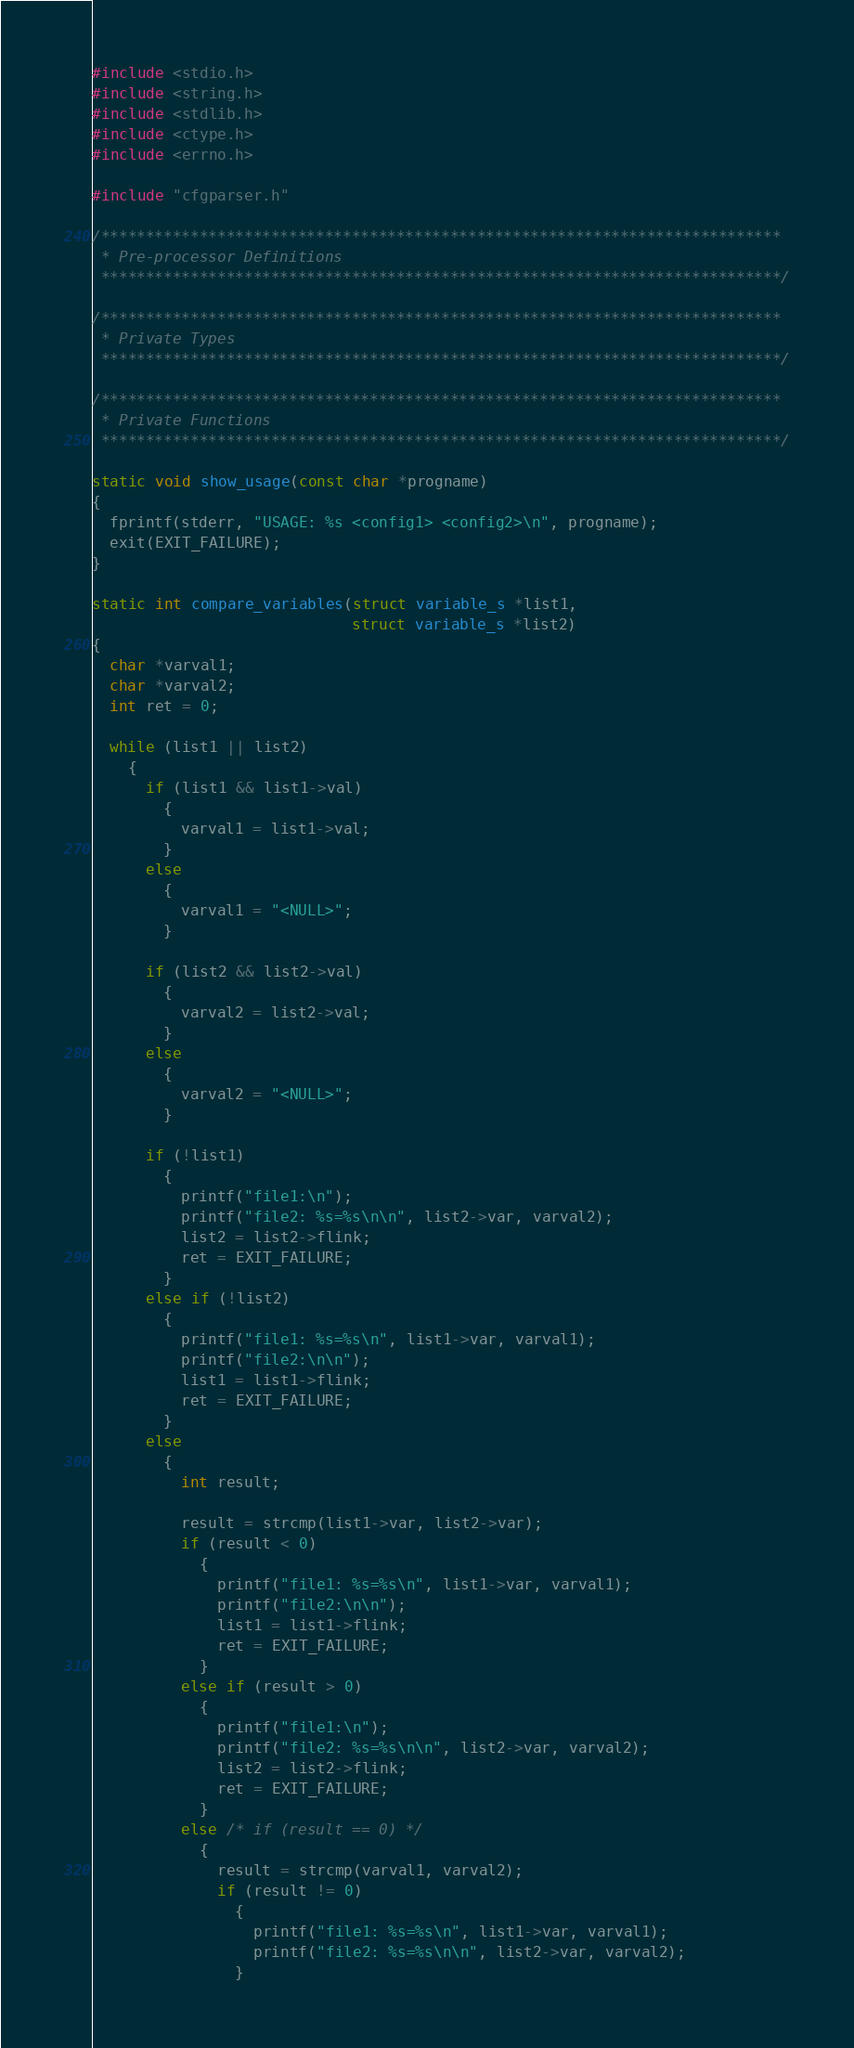Convert code to text. <code><loc_0><loc_0><loc_500><loc_500><_C_>
#include <stdio.h>
#include <string.h>
#include <stdlib.h>
#include <ctype.h>
#include <errno.h>

#include "cfgparser.h"

/****************************************************************************
 * Pre-processor Definitions
 ****************************************************************************/

/****************************************************************************
 * Private Types
 ****************************************************************************/

/****************************************************************************
 * Private Functions
 ****************************************************************************/

static void show_usage(const char *progname)
{
  fprintf(stderr, "USAGE: %s <config1> <config2>\n", progname);
  exit(EXIT_FAILURE);
}

static int compare_variables(struct variable_s *list1,
                             struct variable_s *list2)
{
  char *varval1;
  char *varval2;
  int ret = 0;

  while (list1 || list2)
    {
      if (list1 && list1->val)
        {
          varval1 = list1->val;
        }
      else
        {
          varval1 = "<NULL>";
        }

      if (list2 && list2->val)
        {
          varval2 = list2->val;
        }
      else
        {
          varval2 = "<NULL>";
        }

      if (!list1)
        {
          printf("file1:\n");
          printf("file2: %s=%s\n\n", list2->var, varval2);
          list2 = list2->flink;
          ret = EXIT_FAILURE;
        }
      else if (!list2)
        {
          printf("file1: %s=%s\n", list1->var, varval1);
          printf("file2:\n\n");
          list1 = list1->flink;
          ret = EXIT_FAILURE;
        }
      else
        {
          int result;

          result = strcmp(list1->var, list2->var);
          if (result < 0)
            {
              printf("file1: %s=%s\n", list1->var, varval1);
              printf("file2:\n\n");
              list1 = list1->flink;
              ret = EXIT_FAILURE;
            }
          else if (result > 0)
            {
              printf("file1:\n");
              printf("file2: %s=%s\n\n", list2->var, varval2);
              list2 = list2->flink;
              ret = EXIT_FAILURE;
            }
          else /* if (result == 0) */
            {
              result = strcmp(varval1, varval2);
              if (result != 0)
                {
                  printf("file1: %s=%s\n", list1->var, varval1);
                  printf("file2: %s=%s\n\n", list2->var, varval2);
                }
</code> 